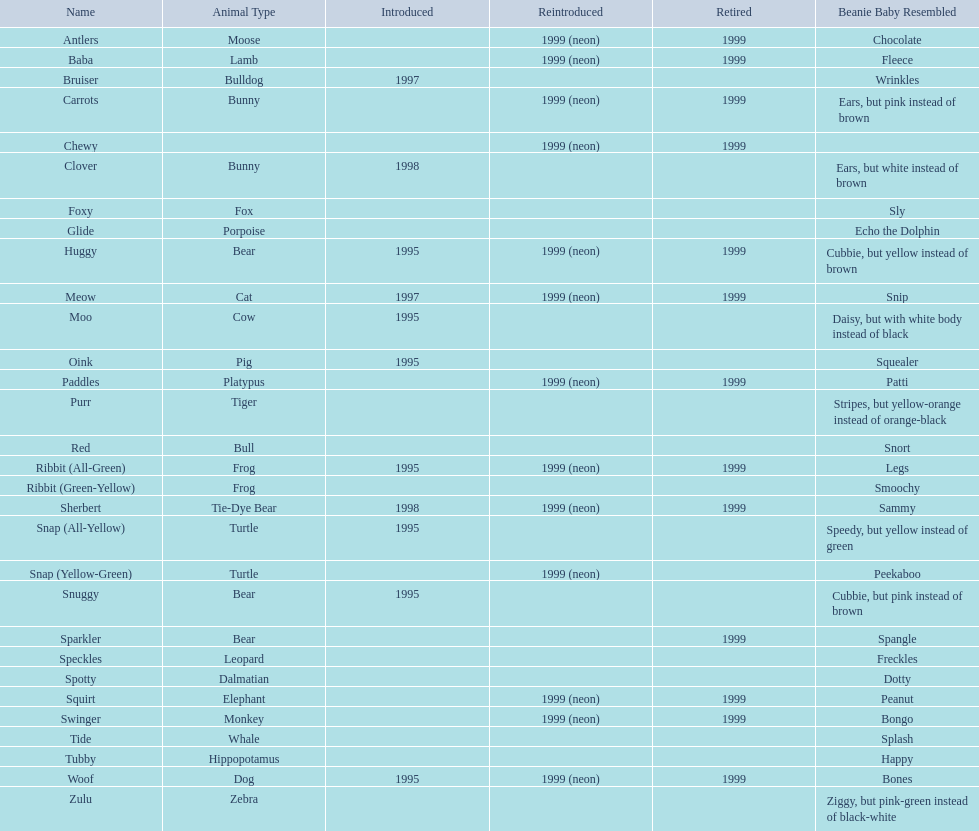What is the name of the pillow pal listed after clover? Foxy. 